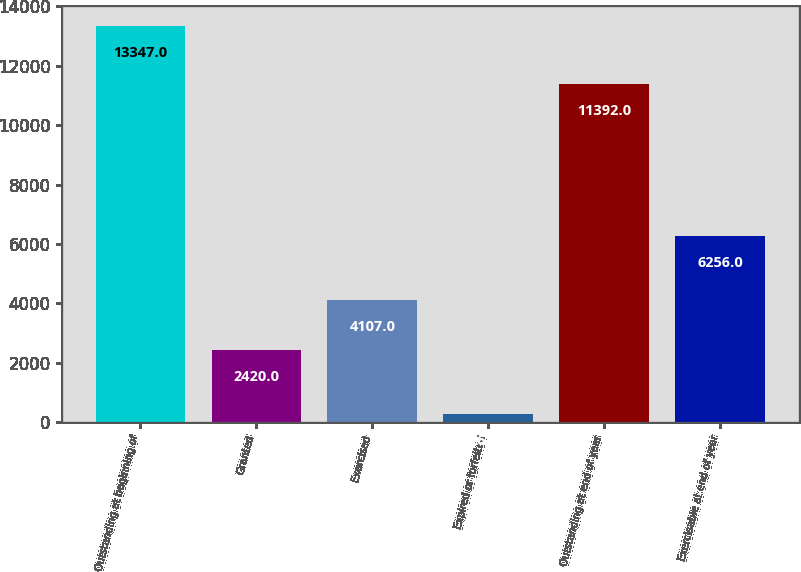Convert chart. <chart><loc_0><loc_0><loc_500><loc_500><bar_chart><fcel>Outstanding at beginning of<fcel>Granted<fcel>Exercised<fcel>Expired or forfeited<fcel>Outstanding at end of year<fcel>Exercisable at end of year<nl><fcel>13347<fcel>2420<fcel>4107<fcel>268<fcel>11392<fcel>6256<nl></chart> 